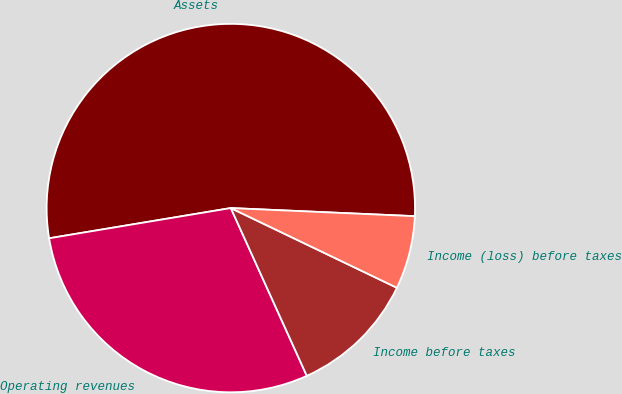Convert chart. <chart><loc_0><loc_0><loc_500><loc_500><pie_chart><fcel>Assets<fcel>Operating revenues<fcel>Income before taxes<fcel>Income (loss) before taxes<nl><fcel>53.33%<fcel>29.15%<fcel>11.11%<fcel>6.42%<nl></chart> 